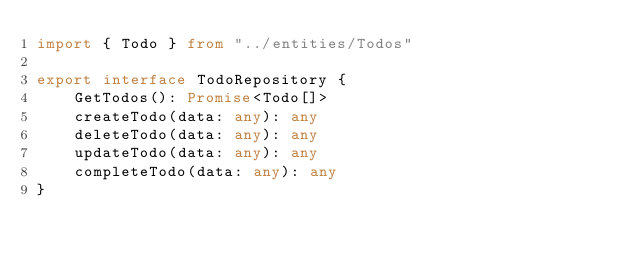Convert code to text. <code><loc_0><loc_0><loc_500><loc_500><_TypeScript_>import { Todo } from "../entities/Todos"

export interface TodoRepository {
    GetTodos(): Promise<Todo[]>
    createTodo(data: any): any
    deleteTodo(data: any): any
    updateTodo(data: any): any
    completeTodo(data: any): any
}
</code> 